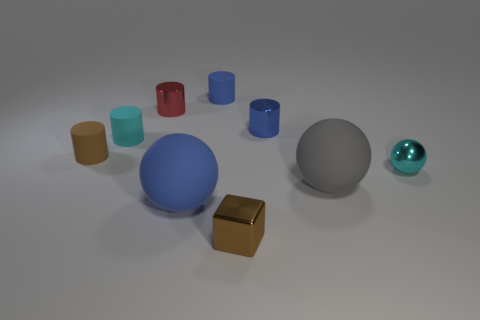Subtract all purple cylinders. Subtract all yellow blocks. How many cylinders are left? 5 Add 1 small brown things. How many objects exist? 10 Subtract all blocks. How many objects are left? 8 Subtract all tiny cubes. Subtract all small cyan shiny objects. How many objects are left? 7 Add 4 big blue rubber balls. How many big blue rubber balls are left? 5 Add 7 tiny cyan blocks. How many tiny cyan blocks exist? 7 Subtract 0 gray cylinders. How many objects are left? 9 